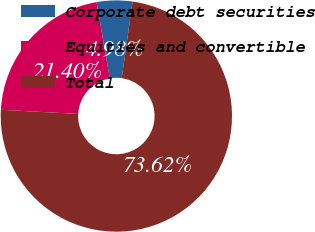<chart> <loc_0><loc_0><loc_500><loc_500><pie_chart><fcel>Corporate debt securities<fcel>Equities and convertible<fcel>Total<nl><fcel>4.98%<fcel>21.4%<fcel>73.63%<nl></chart> 